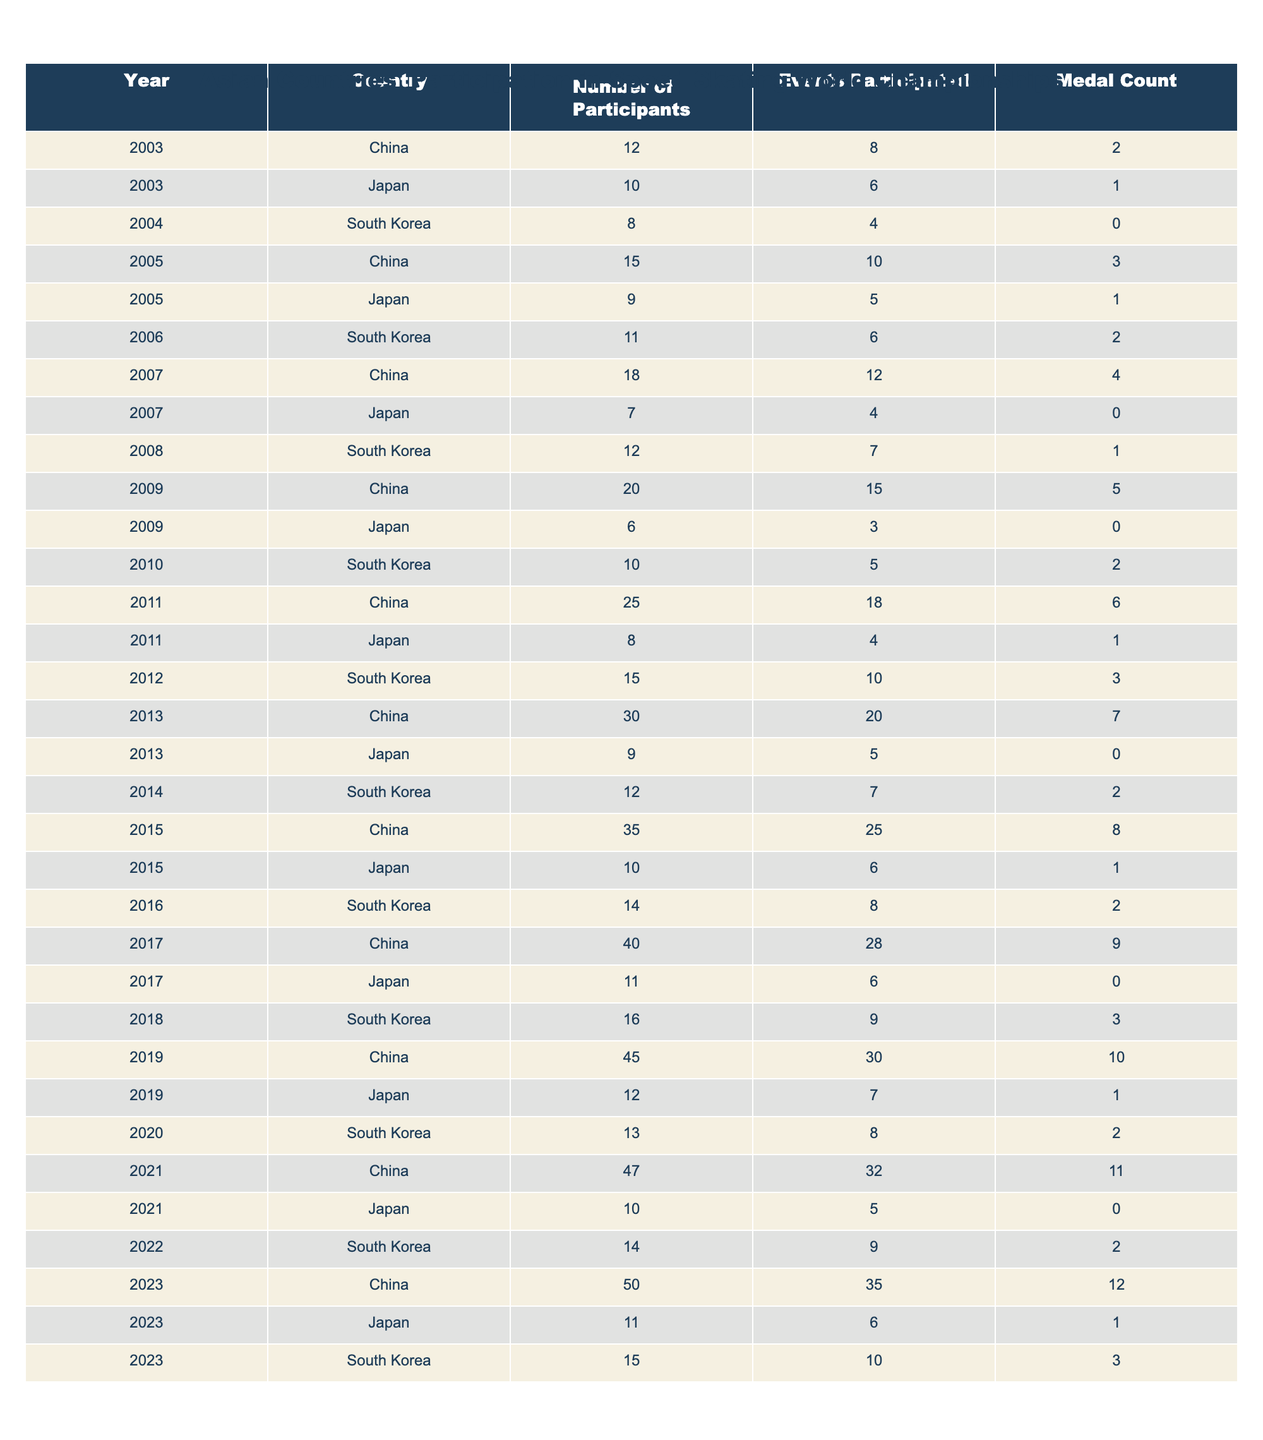What was the highest number of participants from China in a single year? The highest number of participants from China can be found by looking through the "Number of Participants" column for China, which shows 50 participants in 2023 as the maximum value.
Answer: 50 Which country had the lowest number of participants in 2004? By checking the "Number of Participants" for the year 2004, South Korea has the lowest figure with 8 participants compared to China and Japan, which had 12 and 10 participants respectively.
Answer: South Korea In total, how many medals did Japan win from 2003 to 2023? To find the total number of medals for Japan, we sum the "Medal Count" for each year from 2003 to 2023: 1 + 1 + 0 + 1 + 0 + 1 + 0 + 1 + 1 + 0 + 0 + 1 = 7.
Answer: 7 Did South Korea win any medals in 2004? Checking the "Medal Count" for South Korea in 2004, it shows a count of 0, indicating that they did not win any medals that year.
Answer: No What was the average number of participants for Japan over the 20 years? To calculate the average, we sum Japan's participants over the years (10 + 9 + 6 + 8 + 9 + 10 + 11 + 12 + 10 + 10 + 9 + 11 = 131), then divide by the number of entries (13 years), resulting in an average of 131/13 ≈ 10.08.
Answer: 10.08 In which year did China first exceed 30 participants? By examining the data, we find that China exceeded 30 participants in 2013, when it reached 30 participants. This is the earliest occurrence in the data provided.
Answer: 2013 How many events did South Korea participate in the World Championships in 2015? Looking at the "Events Participated" for South Korea in 2015, the table shows 6 events, which indicates their level of participation that year.
Answer: 6 What was the difference in medal counts between China and South Korea in 2021? In 2021, China won 11 medals and South Korea won 2 medals. The difference is calculated as 11 - 2 = 9, indicating how much more successful China was in terms of medal count in that year.
Answer: 9 